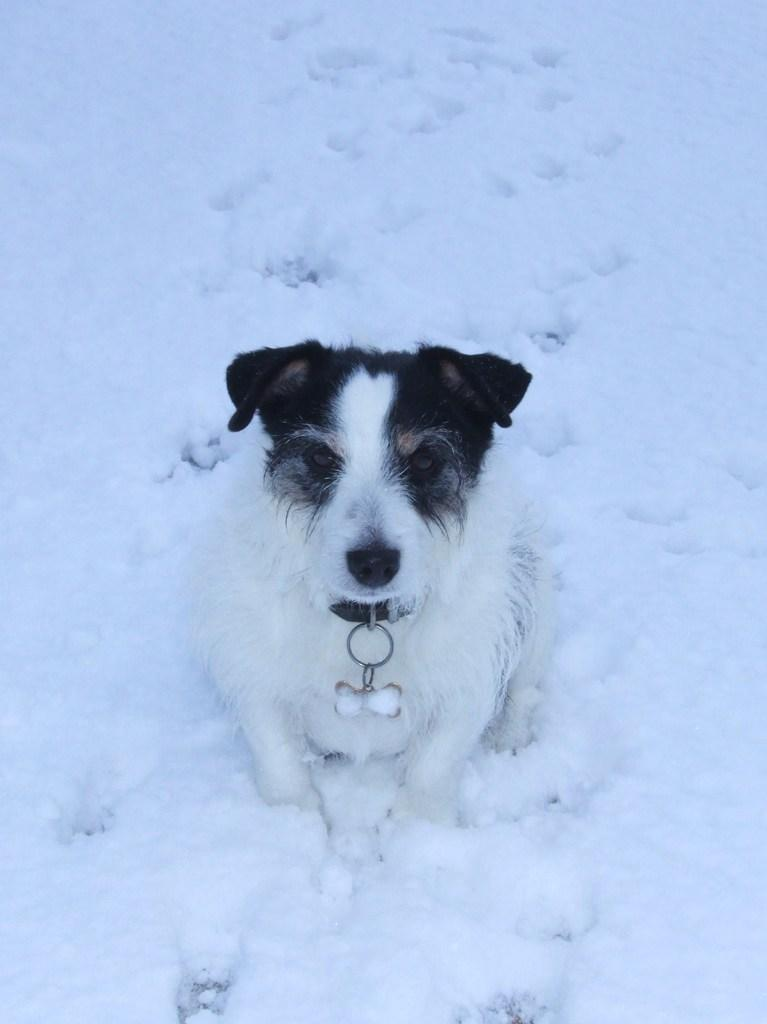What animal can be seen in the image? There is a dog in the image. Where is the dog located in the image? The dog is sitting on the snow. What type of wave can be seen crashing on the shore in the image? There is no wave present in the image; it features a dog sitting on the snow. Is there a stove visible in the image? No, there is no stove present in the image. 